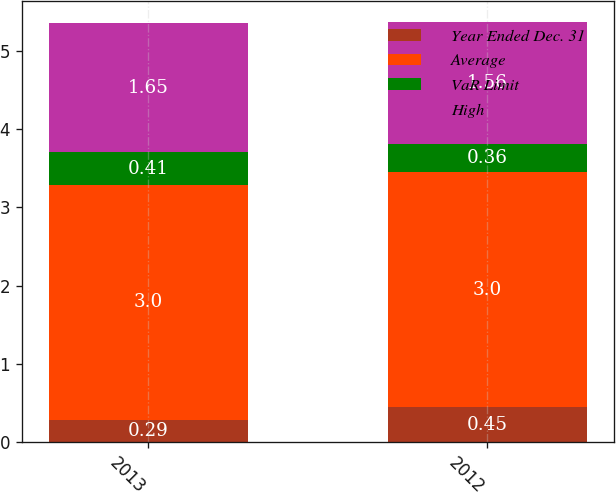Convert chart to OTSL. <chart><loc_0><loc_0><loc_500><loc_500><stacked_bar_chart><ecel><fcel>2013<fcel>2012<nl><fcel>Year Ended Dec. 31<fcel>0.29<fcel>0.45<nl><fcel>Average<fcel>3<fcel>3<nl><fcel>VaR Limit<fcel>0.41<fcel>0.36<nl><fcel>High<fcel>1.65<fcel>1.56<nl></chart> 